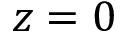Convert formula to latex. <formula><loc_0><loc_0><loc_500><loc_500>z = 0</formula> 